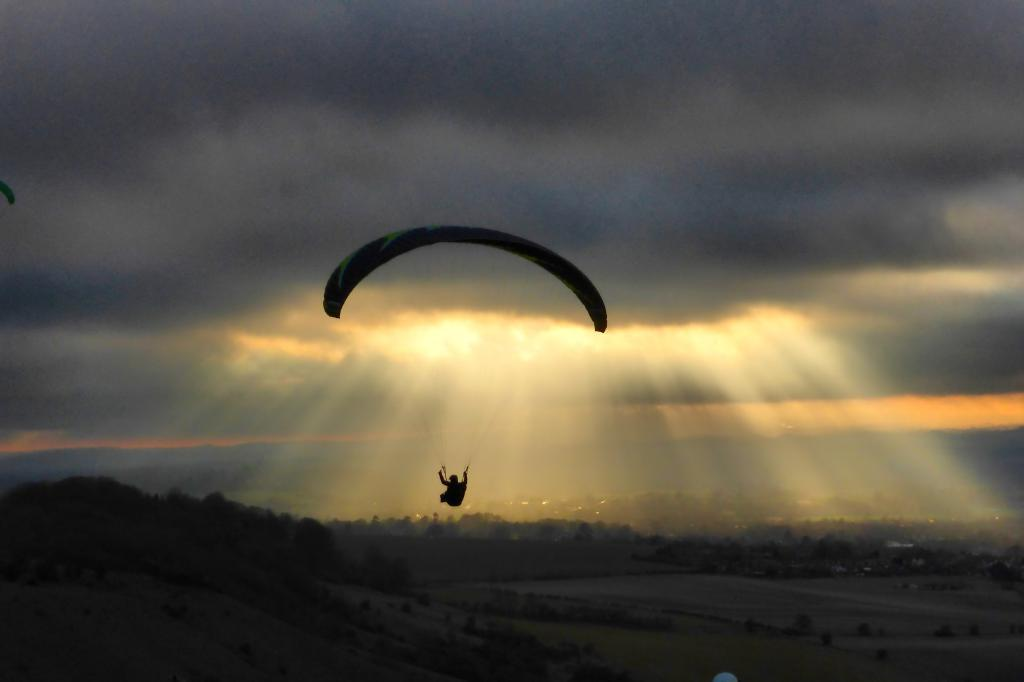What is the person in the image doing? The person is visible on a parachute and flying in the air. What can be seen in the sky in the image? There is a sunset visible in the sky in the image. What type of vegetation is visible in the image? There are trees visible in the image. What type of vest is the person wearing in the image? There is no vest visible in the image; the person is wearing a parachute. 